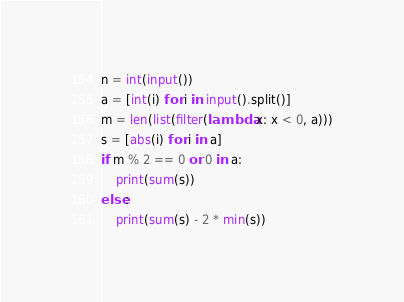Convert code to text. <code><loc_0><loc_0><loc_500><loc_500><_Python_>n = int(input())
a = [int(i) for i in input().split()]
m = len(list(filter(lambda x: x < 0, a)))
s = [abs(i) for i in a]
if m % 2 == 0 or 0 in a:
    print(sum(s))
else:
    print(sum(s) - 2 * min(s))
</code> 